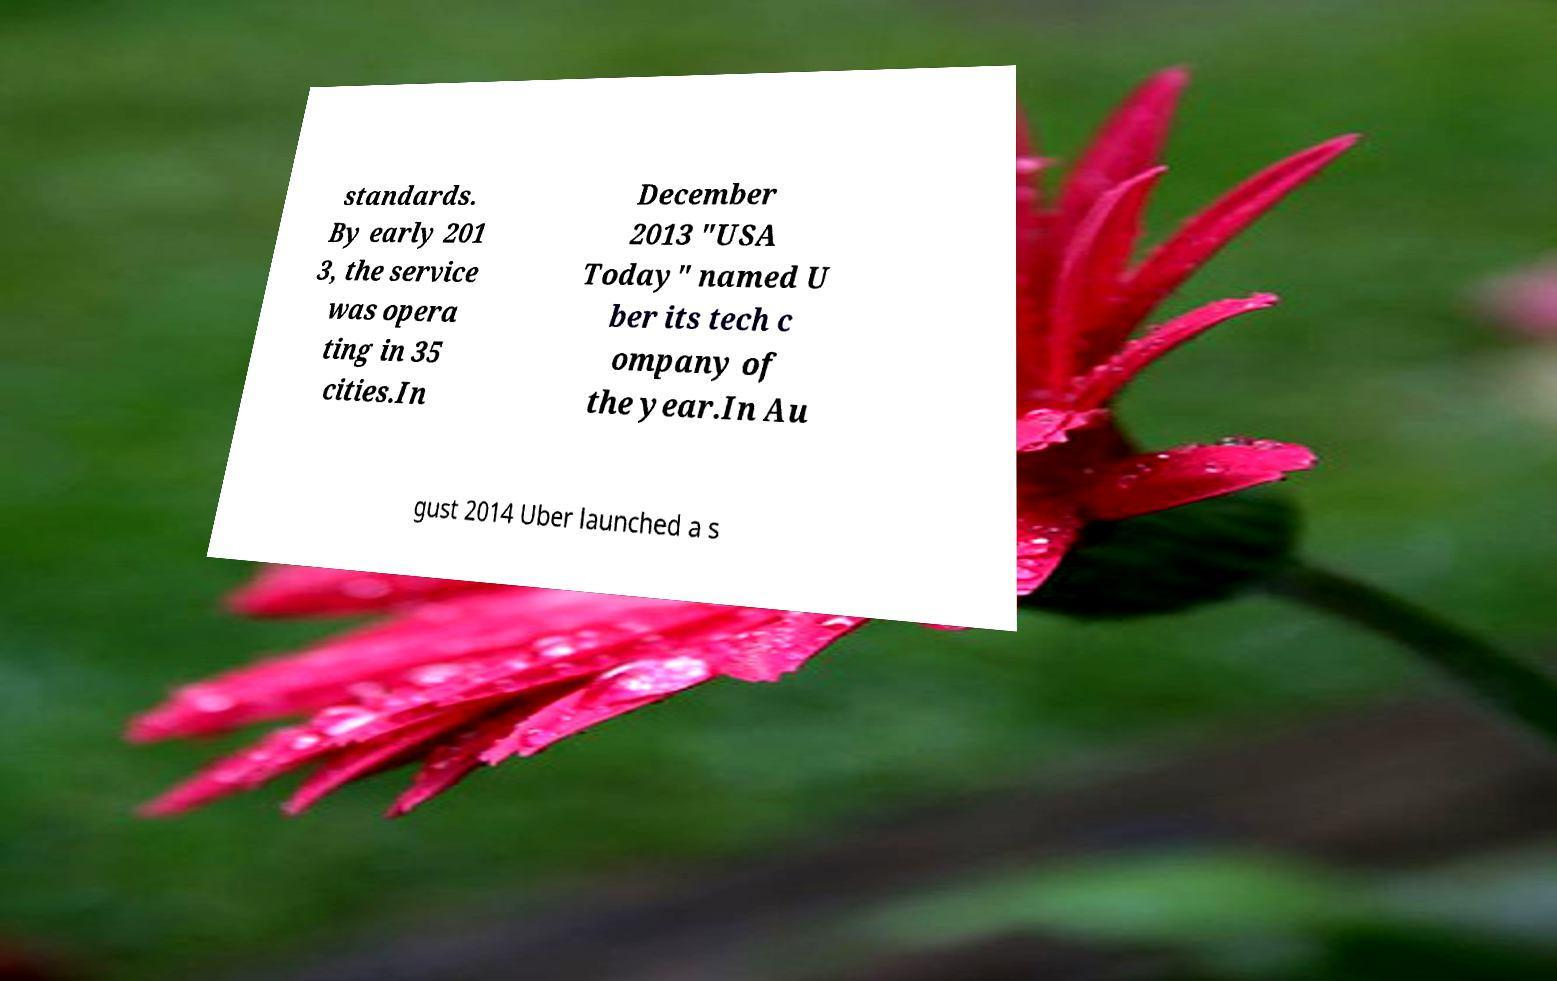Could you assist in decoding the text presented in this image and type it out clearly? standards. By early 201 3, the service was opera ting in 35 cities.In December 2013 "USA Today" named U ber its tech c ompany of the year.In Au gust 2014 Uber launched a s 